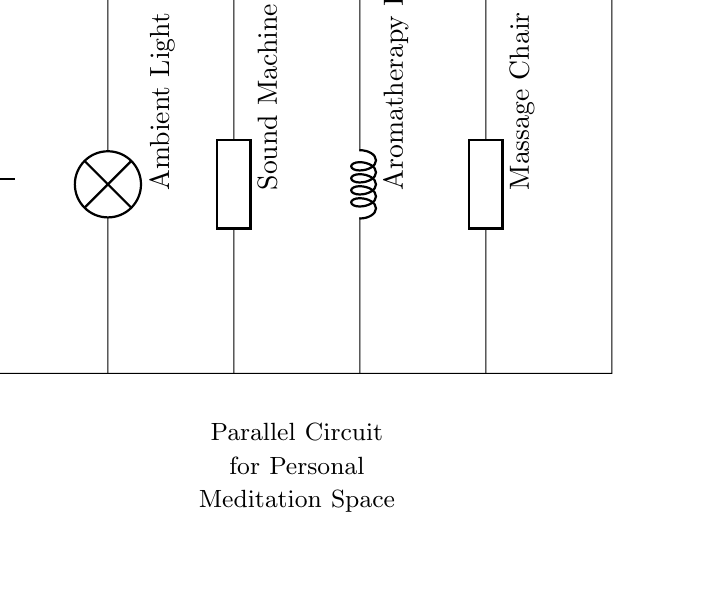What is the main power source in this circuit? The circuit diagram shows a battery labeled as V_s at the top left, indicating that it is the main power source providing voltage.
Answer: battery How many relaxation devices are included in the circuit? By counting the labeled devices connected in parallel, there are four relaxation devices: Ambient Light, Sound Machine, Aromatherapy Diffuser, and Massage Chair.
Answer: four What type of circuit is depicted in this diagram? The circuit diagram features multiple paths for current to flow due to the parallel connections between components, classifying it as a parallel circuit.
Answer: parallel Which component would provide ambient light? The component labeled "Ambient Light" represents the device used to create an enlightening atmosphere conducive to relaxation in the meditation space.
Answer: Ambient Light What happens to the current when one device fails in this circuit? In a parallel circuit, if one device fails, the current will continue to flow to the other devices since they each have their own individual paths to the power source.
Answer: remains unaffected What is the role of the Aromatherapy Diffuser in this circuit? The Aromatherapy Diffuser is one of the devices aimed at enhancing relaxation by dispersing soothing scents, contributing to the overall calming environment of the meditation space.
Answer: enhance relaxation 